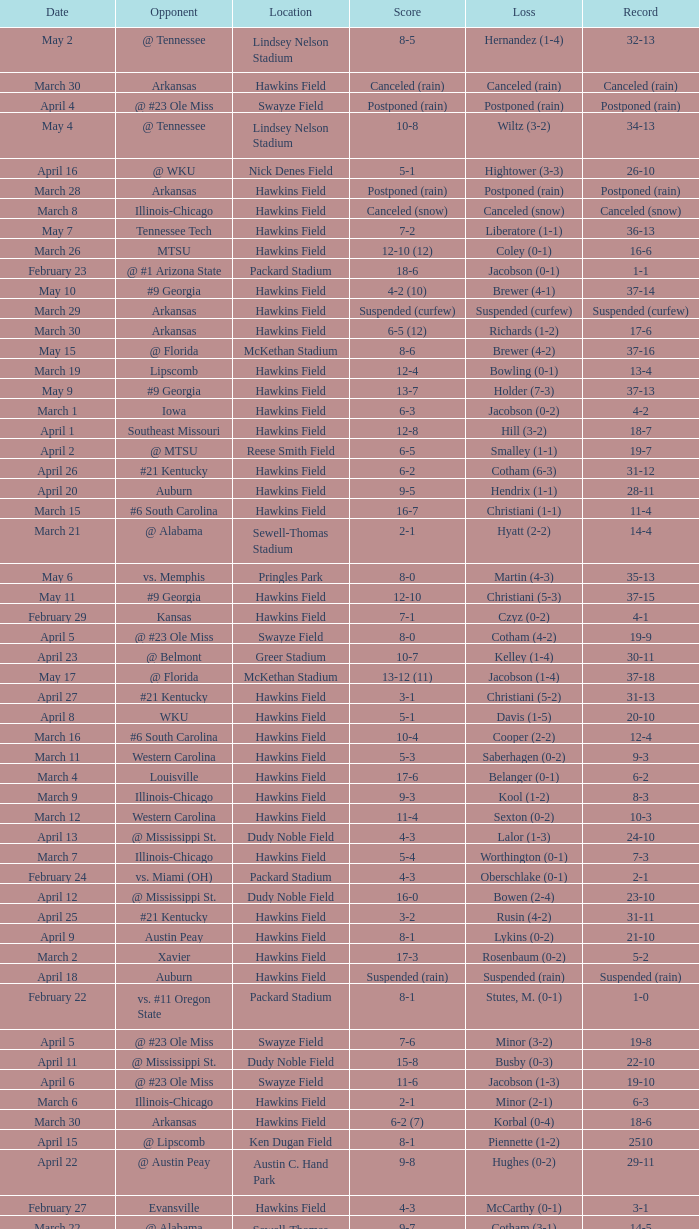What was the location of the game when the record was 2-1? Packard Stadium. I'm looking to parse the entire table for insights. Could you assist me with that? {'header': ['Date', 'Opponent', 'Location', 'Score', 'Loss', 'Record'], 'rows': [['May 2', '@ Tennessee', 'Lindsey Nelson Stadium', '8-5', 'Hernandez (1-4)', '32-13'], ['March 30', 'Arkansas', 'Hawkins Field', 'Canceled (rain)', 'Canceled (rain)', 'Canceled (rain)'], ['April 4', '@ #23 Ole Miss', 'Swayze Field', 'Postponed (rain)', 'Postponed (rain)', 'Postponed (rain)'], ['May 4', '@ Tennessee', 'Lindsey Nelson Stadium', '10-8', 'Wiltz (3-2)', '34-13'], ['April 16', '@ WKU', 'Nick Denes Field', '5-1', 'Hightower (3-3)', '26-10'], ['March 28', 'Arkansas', 'Hawkins Field', 'Postponed (rain)', 'Postponed (rain)', 'Postponed (rain)'], ['March 8', 'Illinois-Chicago', 'Hawkins Field', 'Canceled (snow)', 'Canceled (snow)', 'Canceled (snow)'], ['May 7', 'Tennessee Tech', 'Hawkins Field', '7-2', 'Liberatore (1-1)', '36-13'], ['March 26', 'MTSU', 'Hawkins Field', '12-10 (12)', 'Coley (0-1)', '16-6'], ['February 23', '@ #1 Arizona State', 'Packard Stadium', '18-6', 'Jacobson (0-1)', '1-1'], ['May 10', '#9 Georgia', 'Hawkins Field', '4-2 (10)', 'Brewer (4-1)', '37-14'], ['March 29', 'Arkansas', 'Hawkins Field', 'Suspended (curfew)', 'Suspended (curfew)', 'Suspended (curfew)'], ['March 30', 'Arkansas', 'Hawkins Field', '6-5 (12)', 'Richards (1-2)', '17-6'], ['May 15', '@ Florida', 'McKethan Stadium', '8-6', 'Brewer (4-2)', '37-16'], ['March 19', 'Lipscomb', 'Hawkins Field', '12-4', 'Bowling (0-1)', '13-4'], ['May 9', '#9 Georgia', 'Hawkins Field', '13-7', 'Holder (7-3)', '37-13'], ['March 1', 'Iowa', 'Hawkins Field', '6-3', 'Jacobson (0-2)', '4-2'], ['April 1', 'Southeast Missouri', 'Hawkins Field', '12-8', 'Hill (3-2)', '18-7'], ['April 2', '@ MTSU', 'Reese Smith Field', '6-5', 'Smalley (1-1)', '19-7'], ['April 26', '#21 Kentucky', 'Hawkins Field', '6-2', 'Cotham (6-3)', '31-12'], ['April 20', 'Auburn', 'Hawkins Field', '9-5', 'Hendrix (1-1)', '28-11'], ['March 15', '#6 South Carolina', 'Hawkins Field', '16-7', 'Christiani (1-1)', '11-4'], ['March 21', '@ Alabama', 'Sewell-Thomas Stadium', '2-1', 'Hyatt (2-2)', '14-4'], ['May 6', 'vs. Memphis', 'Pringles Park', '8-0', 'Martin (4-3)', '35-13'], ['May 11', '#9 Georgia', 'Hawkins Field', '12-10', 'Christiani (5-3)', '37-15'], ['February 29', 'Kansas', 'Hawkins Field', '7-1', 'Czyz (0-2)', '4-1'], ['April 5', '@ #23 Ole Miss', 'Swayze Field', '8-0', 'Cotham (4-2)', '19-9'], ['April 23', '@ Belmont', 'Greer Stadium', '10-7', 'Kelley (1-4)', '30-11'], ['May 17', '@ Florida', 'McKethan Stadium', '13-12 (11)', 'Jacobson (1-4)', '37-18'], ['April 27', '#21 Kentucky', 'Hawkins Field', '3-1', 'Christiani (5-2)', '31-13'], ['April 8', 'WKU', 'Hawkins Field', '5-1', 'Davis (1-5)', '20-10'], ['March 16', '#6 South Carolina', 'Hawkins Field', '10-4', 'Cooper (2-2)', '12-4'], ['March 11', 'Western Carolina', 'Hawkins Field', '5-3', 'Saberhagen (0-2)', '9-3'], ['March 4', 'Louisville', 'Hawkins Field', '17-6', 'Belanger (0-1)', '6-2'], ['March 9', 'Illinois-Chicago', 'Hawkins Field', '9-3', 'Kool (1-2)', '8-3'], ['March 12', 'Western Carolina', 'Hawkins Field', '11-4', 'Sexton (0-2)', '10-3'], ['April 13', '@ Mississippi St.', 'Dudy Noble Field', '4-3', 'Lalor (1-3)', '24-10'], ['March 7', 'Illinois-Chicago', 'Hawkins Field', '5-4', 'Worthington (0-1)', '7-3'], ['February 24', 'vs. Miami (OH)', 'Packard Stadium', '4-3', 'Oberschlake (0-1)', '2-1'], ['April 12', '@ Mississippi St.', 'Dudy Noble Field', '16-0', 'Bowen (2-4)', '23-10'], ['April 25', '#21 Kentucky', 'Hawkins Field', '3-2', 'Rusin (4-2)', '31-11'], ['April 9', 'Austin Peay', 'Hawkins Field', '8-1', 'Lykins (0-2)', '21-10'], ['March 2', 'Xavier', 'Hawkins Field', '17-3', 'Rosenbaum (0-2)', '5-2'], ['April 18', 'Auburn', 'Hawkins Field', 'Suspended (rain)', 'Suspended (rain)', 'Suspended (rain)'], ['February 22', 'vs. #11 Oregon State', 'Packard Stadium', '8-1', 'Stutes, M. (0-1)', '1-0'], ['April 5', '@ #23 Ole Miss', 'Swayze Field', '7-6', 'Minor (3-2)', '19-8'], ['April 11', '@ Mississippi St.', 'Dudy Noble Field', '15-8', 'Busby (0-3)', '22-10'], ['April 6', '@ #23 Ole Miss', 'Swayze Field', '11-6', 'Jacobson (1-3)', '19-10'], ['March 6', 'Illinois-Chicago', 'Hawkins Field', '2-1', 'Minor (2-1)', '6-3'], ['March 30', 'Arkansas', 'Hawkins Field', '6-2 (7)', 'Korbal (0-4)', '18-6'], ['April 15', '@ Lipscomb', 'Ken Dugan Field', '8-1', 'Piennette (1-2)', '2510'], ['April 22', '@ Austin Peay', 'Austin C. Hand Park', '9-8', 'Hughes (0-2)', '29-11'], ['February 27', 'Evansville', 'Hawkins Field', '4-3', 'McCarthy (0-1)', '3-1'], ['March 22', '@ Alabama', 'Sewell-Thomas Stadium', '9-7', 'Cotham (3-1)', '14-5'], ['April 19', 'Auburn', 'Hawkins Field', '8-2', 'Luckie (4-4)', '27-11'], ['March 14', '#6 South Carolina', 'Hawkins Field', '4-3 (13)', 'Todd (0-1)', '11-3'], ['April 19', 'Auburn', 'Hawkins Field', '6-3', 'Minor (4-3)', '26-11'], ['May 3', '@ Tennessee', 'Lindsey Nelson Stadium', '9-2', 'Morgado (5-3)', '33-13'], ['March 23', '@ Alabama', 'Sewell-Thomas Stadium', '10-3', 'Hill (1-1)', '14-6'], ['March 25', 'Belmont', 'Hawkins Field', '7-3', 'Woods (0-1)', '15-6'], ['May 16', '@ Florida', 'McKethan Stadium', '5-4', 'Cotham (7-4)', '37-17']]} 